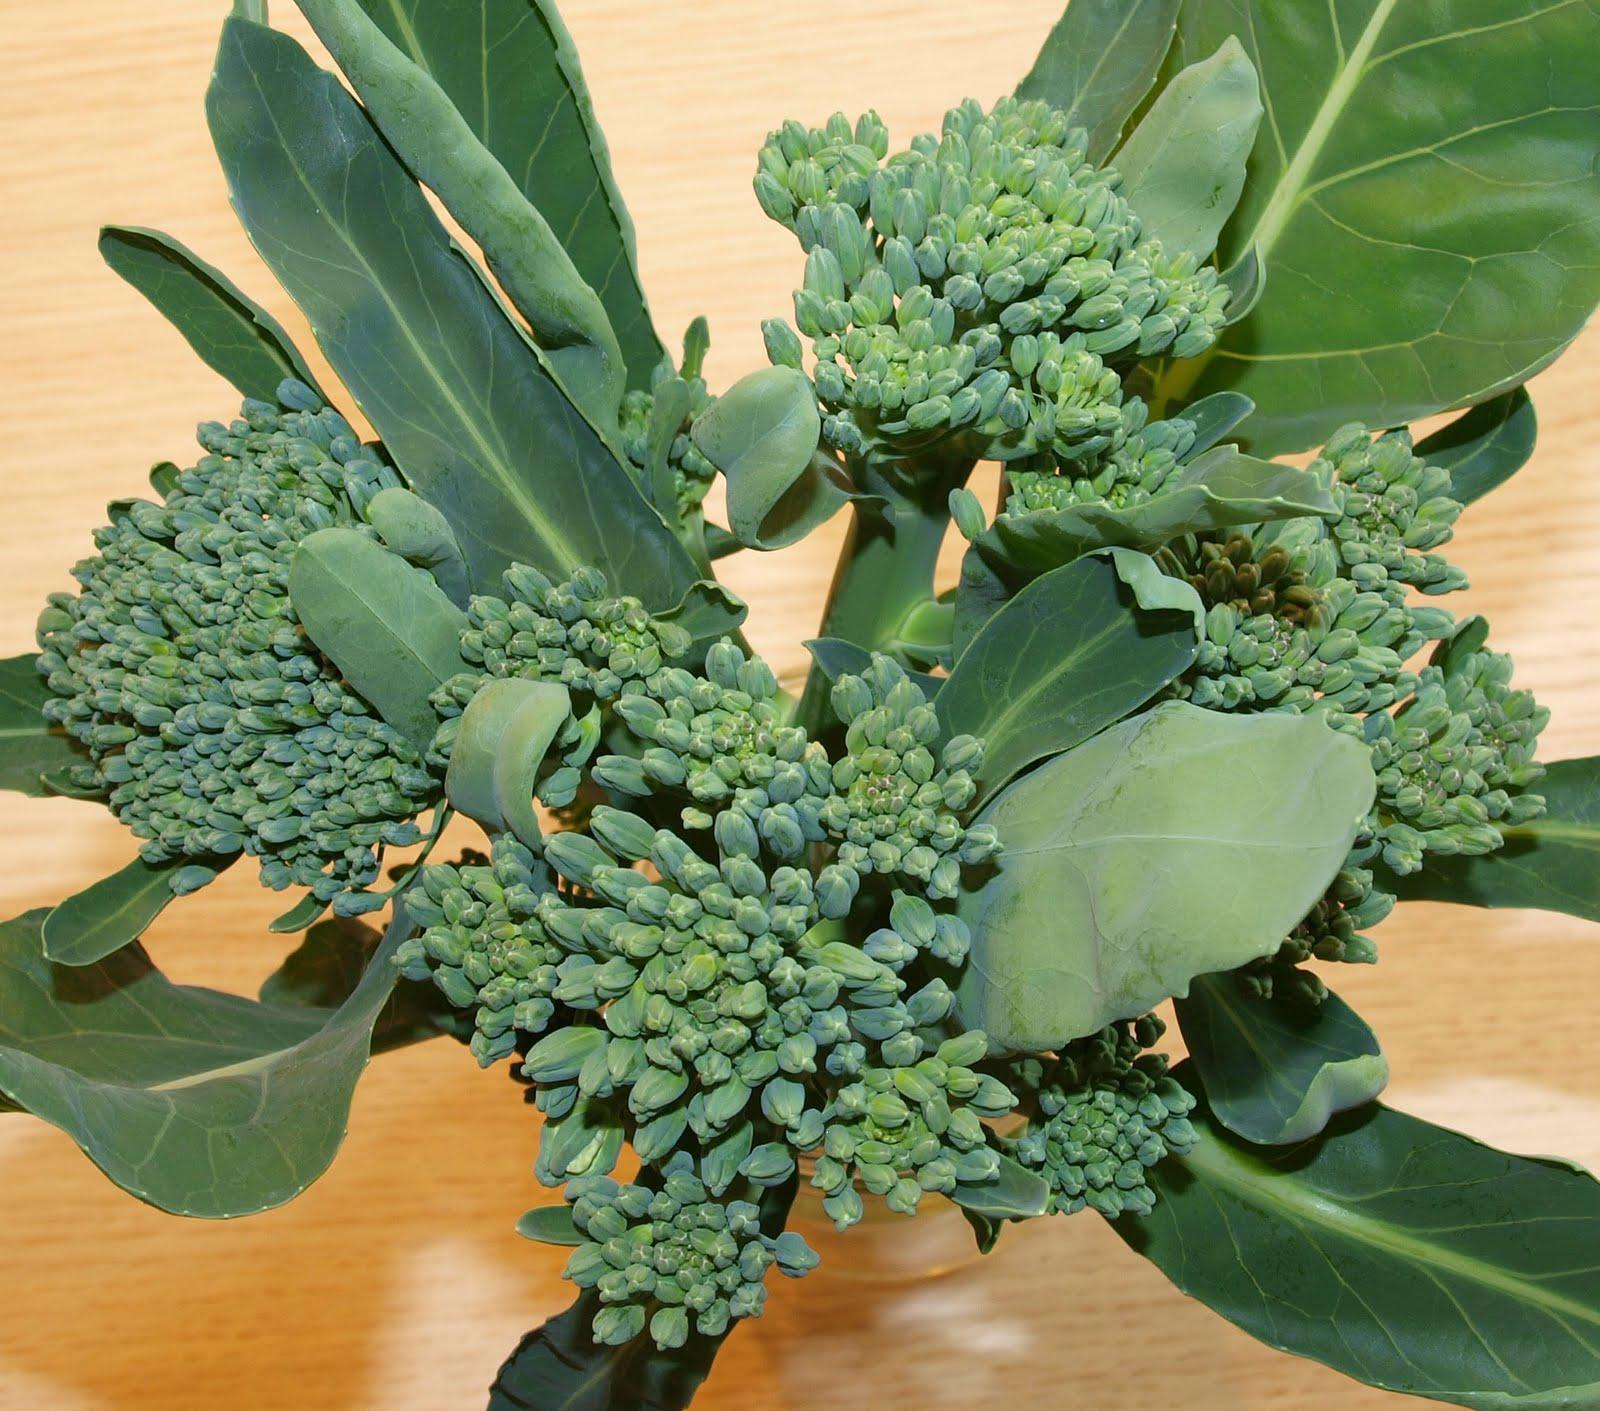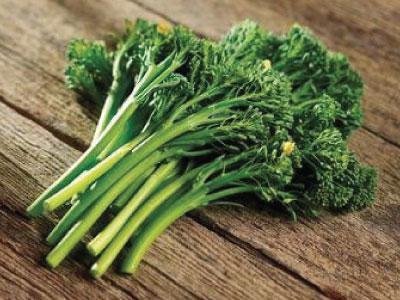The first image is the image on the left, the second image is the image on the right. Considering the images on both sides, is "One photo shows vegetables lying on a rough wooden surface." valid? Answer yes or no. Yes. The first image is the image on the left, the second image is the image on the right. Assess this claim about the two images: "One of the vegetables has purple colored sprouts.". Correct or not? Answer yes or no. No. 